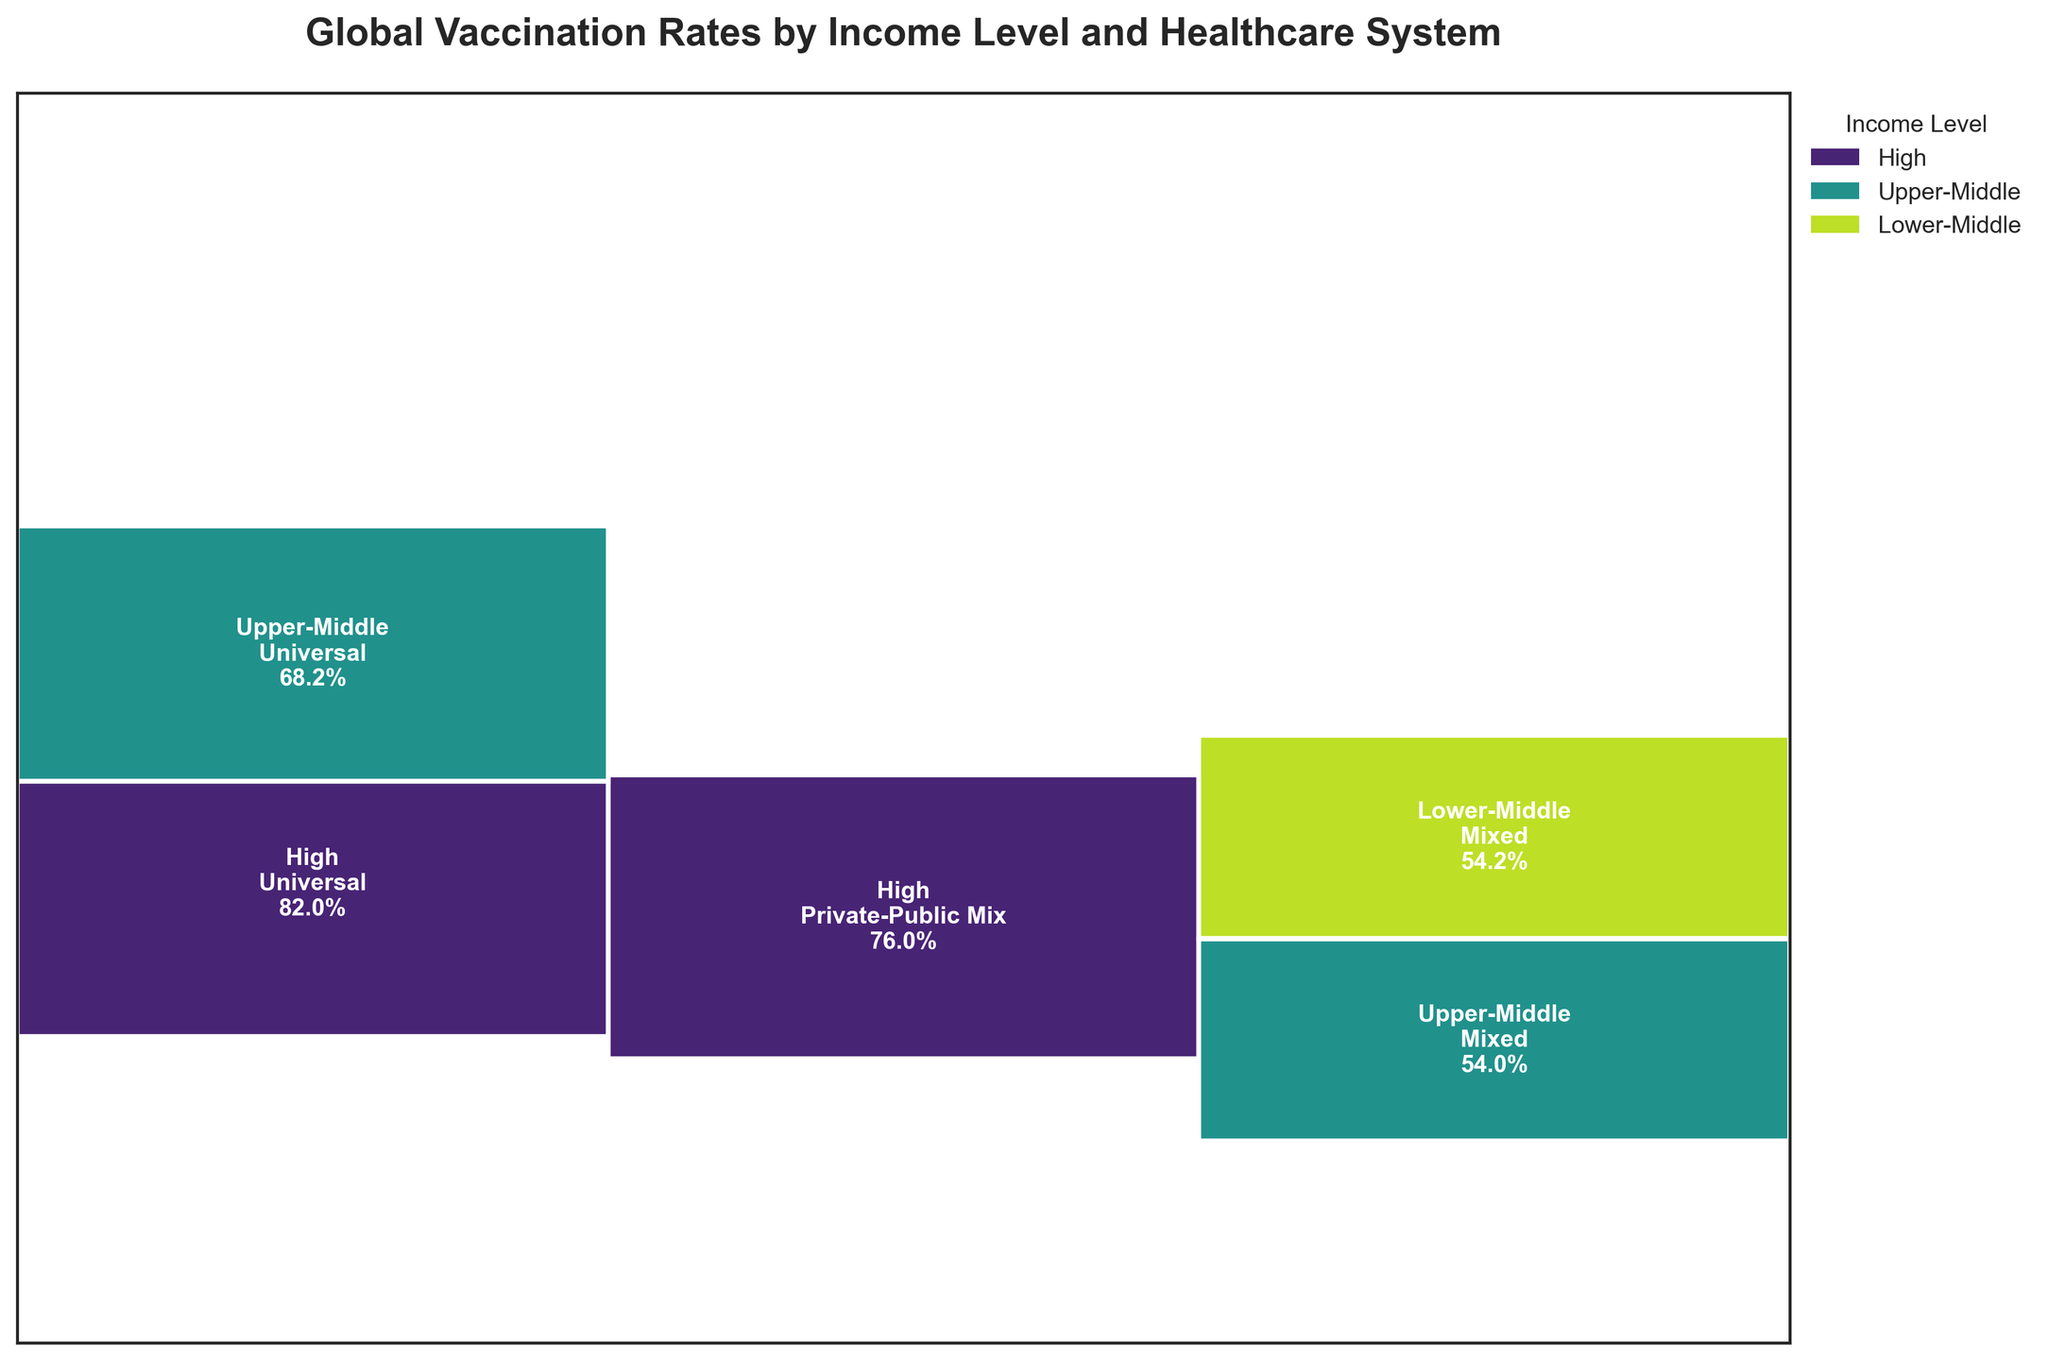What is the title of the plot? The title is usually displayed at the top of the plot and succinctly describes what the plot depicts.
Answer: Global Vaccination Rates by Income Level and Healthcare System What income level and healthcare system have the highest vaccination rate? To find this, look for the largest rectangle, and then read the corresponding income level and healthcare system displayed on it. The values are normalized, so the largest ratio will point to the highest rate.
Answer: High income, Universal healthcare system Which income level has the smallest section in terms of total area? To determine this, visually inspect the plot's segments distributed across the three income levels and identify the one with the least total area.
Answer: Lower-Middle income What is the vaccination rate for High-income countries with Universal healthcare systems? Locate the rectangle for High-income and Universal healthcare systems, and read the vaccination rate displayed inside.
Answer: 83% How does the vaccination rate in high-income countries with private-public mixed healthcare compare to those with a universal system? Compare the vertical heights of the rectangles belonging to High-income with the labels of Private-Public Mix and Universal, respectively.
Answer: Universal is higher (83%) compared to Private-Public Mix (76%) Which income level and healthcare system combination have the least amount of space in the plot? Find the smallest rectangle in the plot and read its corresponding income level and healthcare system labels.
Answer: Lower-Middle income, Mixed healthcare system What's the average vaccination rate for Upper-Middle income level? Calculate the average vaccination rate of all the rectangles under Upper-Middle income, considering the indicated values and dividing by 4 (number of systems).
Answer: (73 + 85 + 65 + 50) / 4 = 68.25% How many different healthcare system types are represented in the plot? Count the distinct healthcare system types shown at the bottom of the plot or above the rectangles.
Answer: 3 Does the plot suggest that income level affects vaccination rates? Compare the general heights and prevalence of rectangles across different income levels to determine if higher income levels generally show greater vaccination rates.
Answer: Yes Which type of healthcare system is seen most frequently in High-income countries according to the plot? Observe the distribution of healthcare system types within the high-income category.
Answer: Universal 